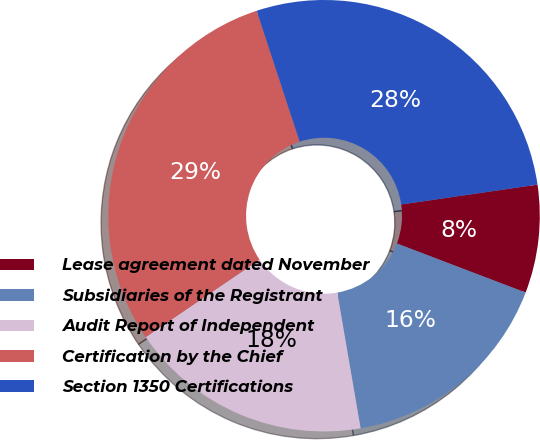<chart> <loc_0><loc_0><loc_500><loc_500><pie_chart><fcel>Lease agreement dated November<fcel>Subsidiaries of the Registrant<fcel>Audit Report of Independent<fcel>Certification by the Chief<fcel>Section 1350 Certifications<nl><fcel>8.1%<fcel>16.49%<fcel>18.2%<fcel>29.46%<fcel>27.75%<nl></chart> 